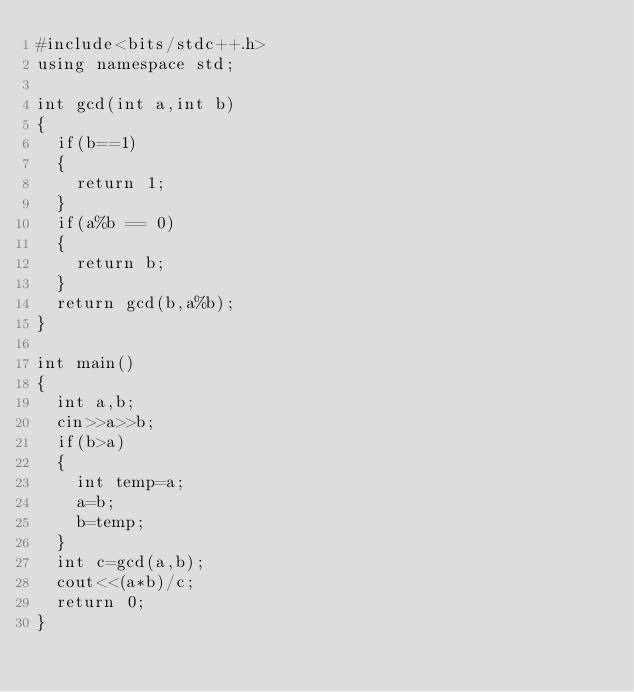Convert code to text. <code><loc_0><loc_0><loc_500><loc_500><_C++_>#include<bits/stdc++.h>
using namespace std;

int gcd(int a,int b)
{
	if(b==1)
	{
		return 1;
	}
	if(a%b == 0)
	{
		return b;
	}
	return gcd(b,a%b);
}

int main()
{
	int a,b;
	cin>>a>>b;
	if(b>a)
	{
		int temp=a;
		a=b;
		b=temp;
	}
	int	c=gcd(a,b);
	cout<<(a*b)/c;
	return 0;
}</code> 